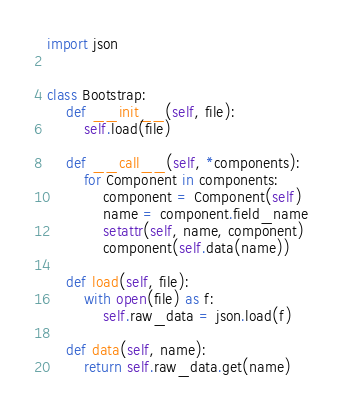Convert code to text. <code><loc_0><loc_0><loc_500><loc_500><_Python_>import json


class Bootstrap:
    def __init__(self, file):
        self.load(file)

    def __call__(self, *components):
        for Component in components:
            component = Component(self)
            name = component.field_name
            setattr(self, name, component)
            component(self.data(name))

    def load(self, file):
        with open(file) as f:
            self.raw_data = json.load(f)

    def data(self, name):
        return self.raw_data.get(name)
</code> 